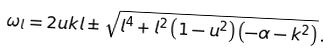<formula> <loc_0><loc_0><loc_500><loc_500>\omega _ { l } = 2 u k l \pm \sqrt { l ^ { 4 } + l ^ { 2 } \left ( 1 - u ^ { 2 } \right ) \left ( - \alpha - k ^ { 2 } \right ) } \, .</formula> 